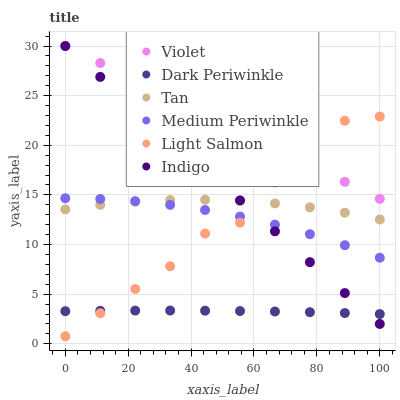Does Dark Periwinkle have the minimum area under the curve?
Answer yes or no. Yes. Does Violet have the maximum area under the curve?
Answer yes or no. Yes. Does Indigo have the minimum area under the curve?
Answer yes or no. No. Does Indigo have the maximum area under the curve?
Answer yes or no. No. Is Indigo the smoothest?
Answer yes or no. Yes. Is Light Salmon the roughest?
Answer yes or no. Yes. Is Medium Periwinkle the smoothest?
Answer yes or no. No. Is Medium Periwinkle the roughest?
Answer yes or no. No. Does Light Salmon have the lowest value?
Answer yes or no. Yes. Does Indigo have the lowest value?
Answer yes or no. No. Does Violet have the highest value?
Answer yes or no. Yes. Does Medium Periwinkle have the highest value?
Answer yes or no. No. Is Dark Periwinkle less than Violet?
Answer yes or no. Yes. Is Violet greater than Medium Periwinkle?
Answer yes or no. Yes. Does Dark Periwinkle intersect Indigo?
Answer yes or no. Yes. Is Dark Periwinkle less than Indigo?
Answer yes or no. No. Is Dark Periwinkle greater than Indigo?
Answer yes or no. No. Does Dark Periwinkle intersect Violet?
Answer yes or no. No. 